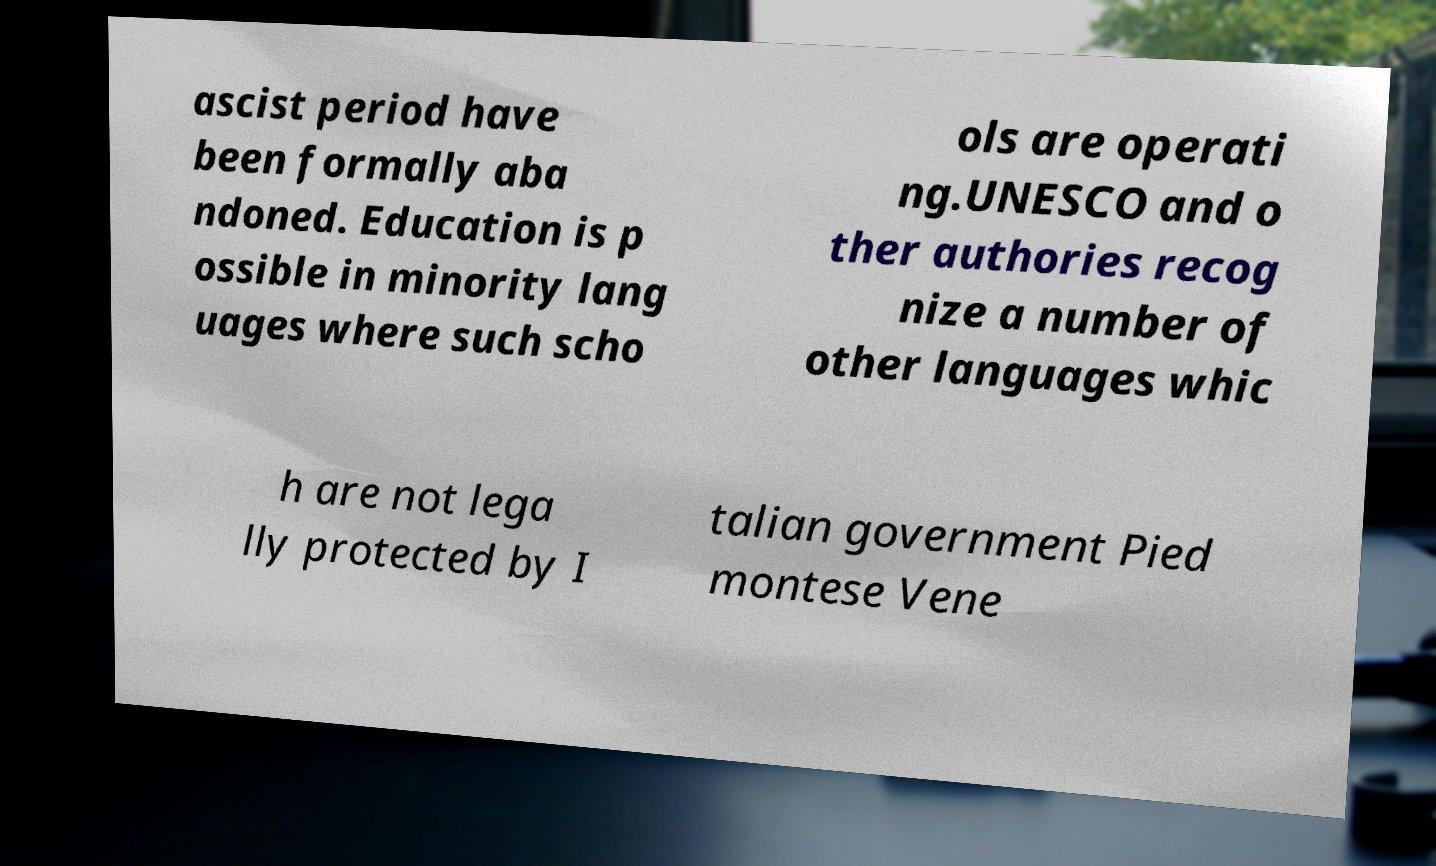I need the written content from this picture converted into text. Can you do that? ascist period have been formally aba ndoned. Education is p ossible in minority lang uages where such scho ols are operati ng.UNESCO and o ther authories recog nize a number of other languages whic h are not lega lly protected by I talian government Pied montese Vene 